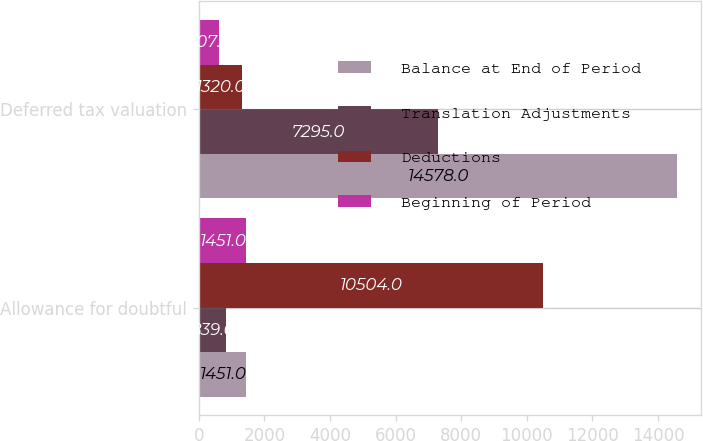Convert chart. <chart><loc_0><loc_0><loc_500><loc_500><stacked_bar_chart><ecel><fcel>Allowance for doubtful<fcel>Deferred tax valuation<nl><fcel>Balance at End of Period<fcel>1451<fcel>14578<nl><fcel>Translation Adjustments<fcel>839<fcel>7295<nl><fcel>Deductions<fcel>10504<fcel>1320<nl><fcel>Beginning of Period<fcel>1451<fcel>607<nl></chart> 